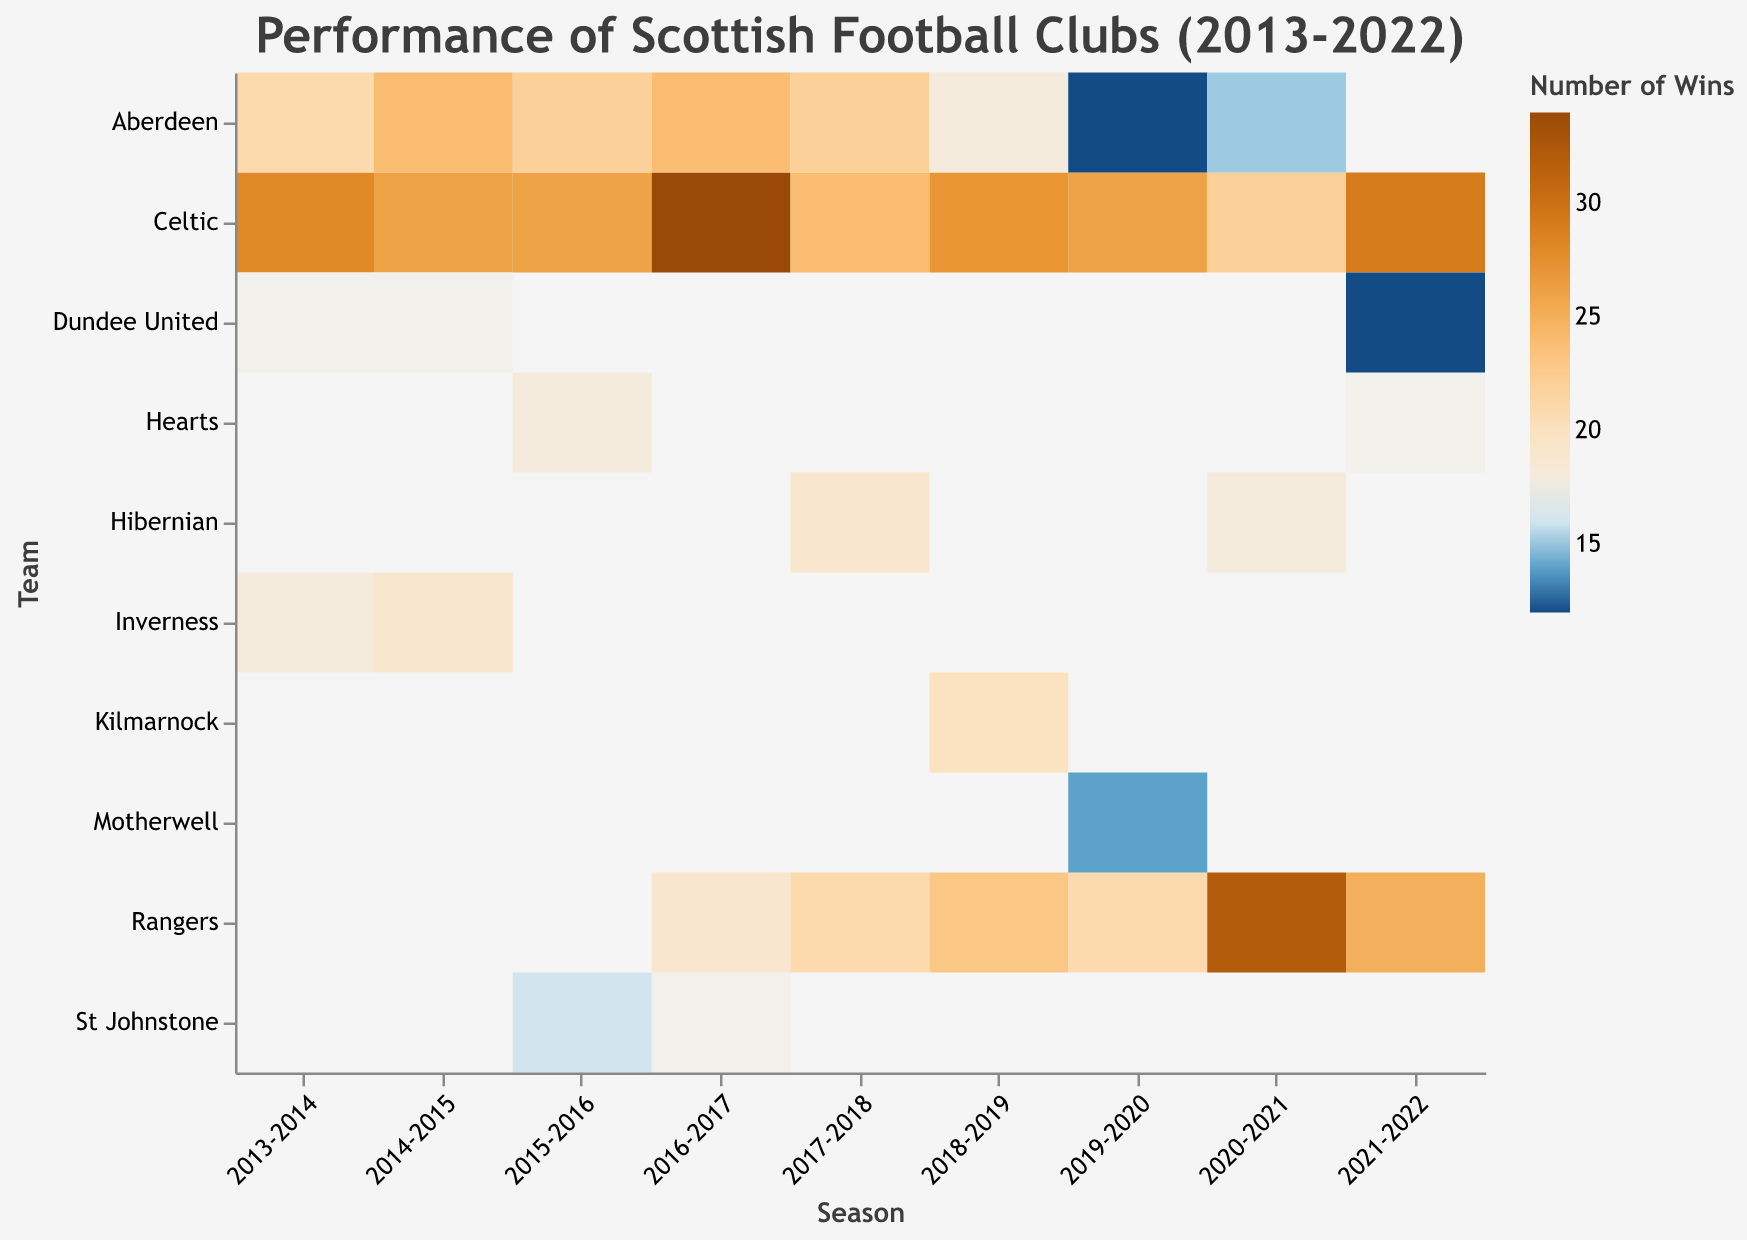Which team had the most wins in the 2016-2017 season? Based on the heatmap, look at the '2016-2017' column and find the team with the darkest color indicating the highest number of wins.
Answer: Celtic What are the total draws for Rangers between 2016 and 2022? Find the number of draws for Rangers for each season between '2016-2017' and '2021-2022' and sum them up. The draws are: 10 (2016-2017), 7 (2017-2018), 9 (2018-2019), 4 (2019-2020), 6 (2020-2021), and 8 (2021-2022). Adding these together gives 10 + 7 + 9 + 4 + 6 + 8 = 44
Answer: 44 Which season did Celtic have an unbeaten record in terms of losses? Look through the seasons under Celtic for the lightest cell indicating zero losses. The '2016-2017' season shows Celtic with zero losses.
Answer: 2016-2017 Compare the win records of Aberdeen and Dundee United in the 2013-2014 season. Who had more wins and by how many? Look at the '2013-2014' column for both Aberdeen and Dundee United. Aberdeen had 21 wins, and Dundee United had 17 wins. Subtract Dundee United's wins from Aberdeen's: 21 - 17 = 4.
Answer: Aberdeen by 4 In which season did Rangers achieve the most wins? Find the darkest cell under the 'Rangers' row, which corresponds to the highest number of wins. The '2020-2021' season shows Rangers with the darkest cell indicating 32 wins.
Answer: 2020-2021 What is the average number of wins for Hibernian in the seasons they participated in? Hibernian participates in three seasons: '2017-2018', '2020-2021', and '2021-2022'. Their wins are 19, 18, and 17, respectively. Sum these to get 19 + 18 + 17 = 54 and divide by 3 for the average: 54 / 3 = 18.
Answer: 18 Which team had the least number of wins in the 2021-2022 season? Look at the '2021-2022' column and find the team with the lightest color indicating the fewest wins. Dundee United has the least number of wins with 12.
Answer: Dundee United How many more wins did Celtic have compared to Aberdeen in the 2018-2019 season? Look at the '2018-2019' column for both Celtic and Aberdeen. Celtic had 27 wins and Aberdeen had 18 wins. Subtract Aberdeen's wins from Celtic's: 27 - 18 = 9.
Answer: 9 What was the highest number of losses for Hearts in a single season? Look at the seasons under Hearts. The number of losses for each season is 8 (2015-2016) and 11 (2021-2022). The highest is 11.
Answer: 11 